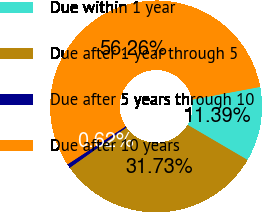<chart> <loc_0><loc_0><loc_500><loc_500><pie_chart><fcel>Due within 1 year<fcel>Due after 1 year through 5<fcel>Due after 5 years through 10<fcel>Due after 10 years<nl><fcel>11.39%<fcel>31.73%<fcel>0.62%<fcel>56.26%<nl></chart> 